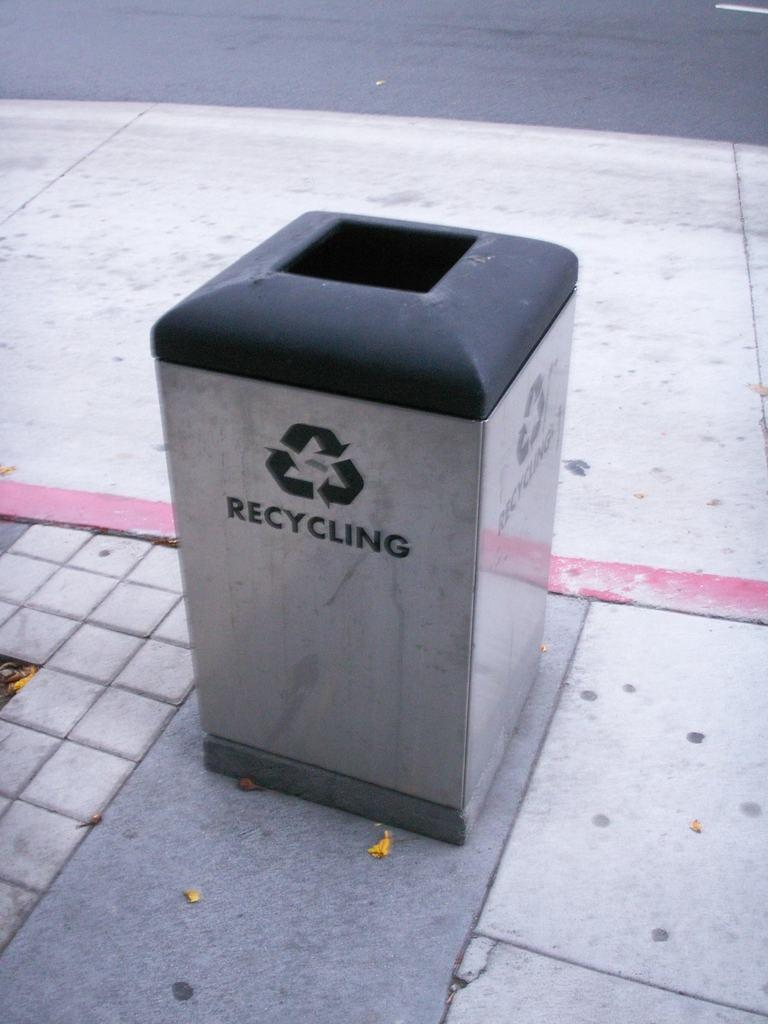<image>
Describe the image concisely. A silver recycling container sits near a red-painted curb. 